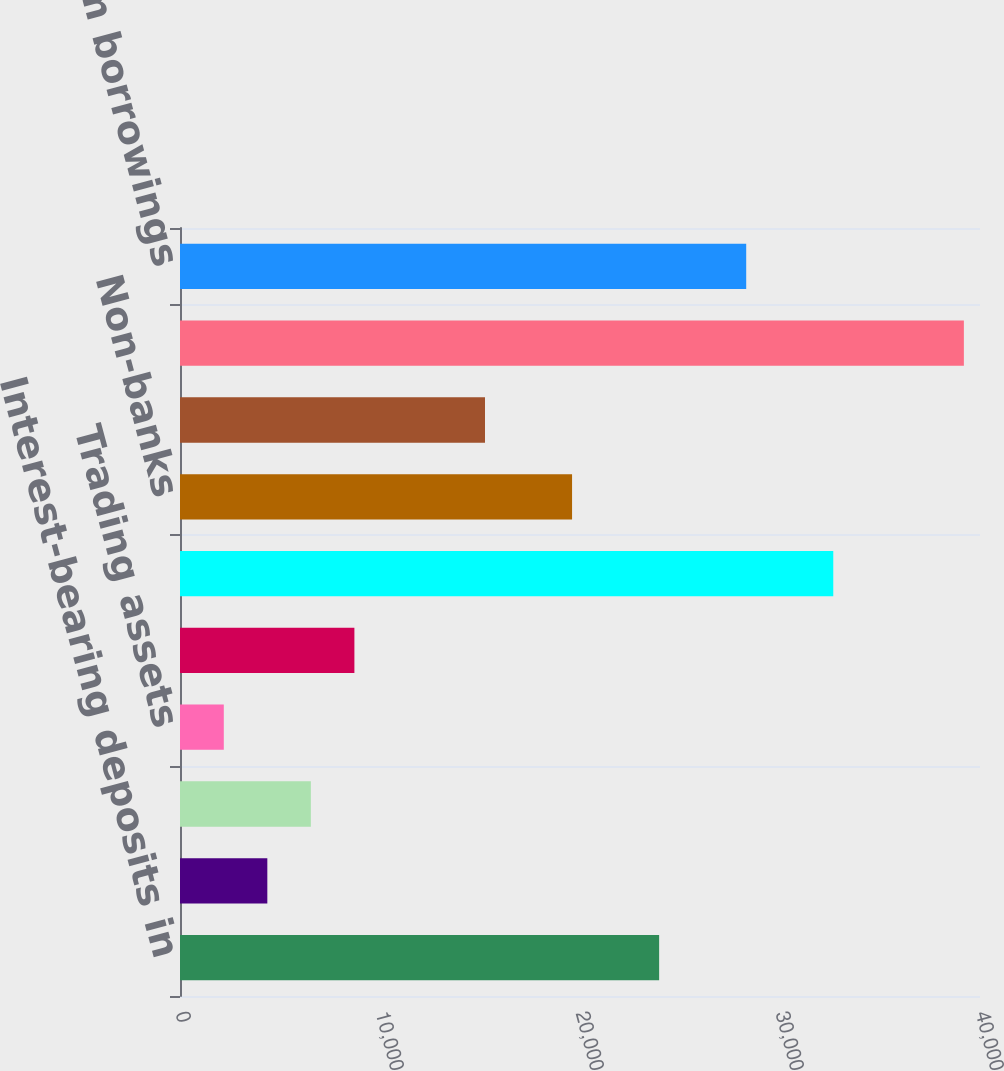Convert chart. <chart><loc_0><loc_0><loc_500><loc_500><bar_chart><fcel>Interest-bearing deposits in<fcel>Loans to subsidiaries<fcel>Securities available for sale<fcel>Trading assets<fcel>Premises and equipment<fcel>Banks<fcel>Non-banks<fcel>Other assets<fcel>Total assets<fcel>Long-term borrowings<nl><fcel>23956.7<fcel>4366.4<fcel>6543.1<fcel>2189.7<fcel>8719.8<fcel>32663.5<fcel>19603.3<fcel>15249.9<fcel>39193.6<fcel>28310.1<nl></chart> 